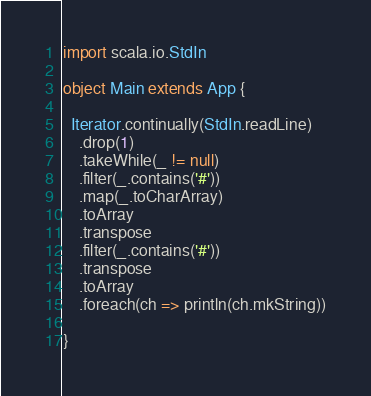<code> <loc_0><loc_0><loc_500><loc_500><_Scala_>import scala.io.StdIn

object Main extends App {

  Iterator.continually(StdIn.readLine)
    .drop(1)
    .takeWhile(_ != null)
    .filter(_.contains('#'))
    .map(_.toCharArray)
    .toArray
    .transpose
    .filter(_.contains('#'))
    .transpose
    .toArray
    .foreach(ch => println(ch.mkString))

}</code> 